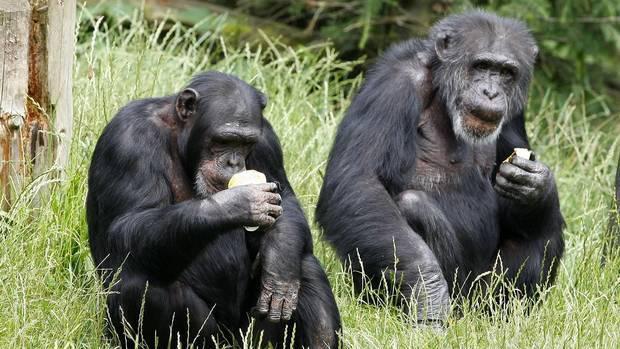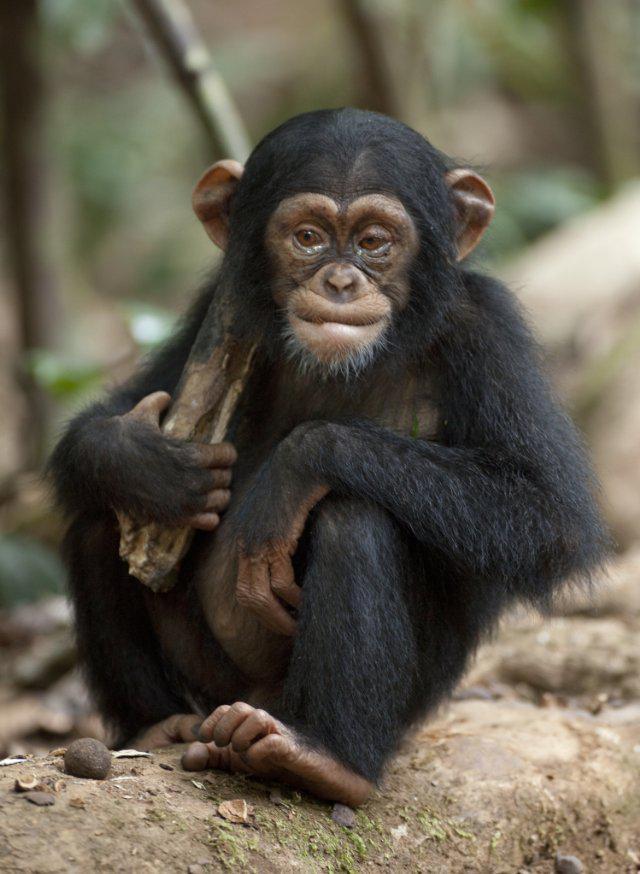The first image is the image on the left, the second image is the image on the right. Considering the images on both sides, is "A baboon is carrying a baby baboon in the image on the right." valid? Answer yes or no. No. 